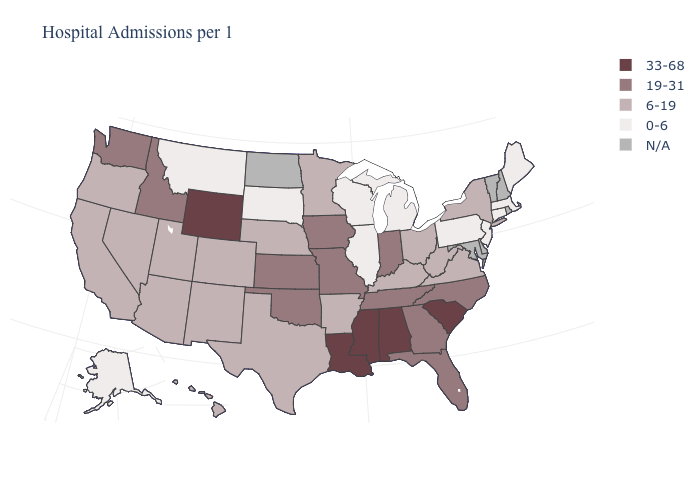Which states have the lowest value in the South?
Answer briefly. Arkansas, Kentucky, Texas, Virginia, West Virginia. Among the states that border Nevada , does Idaho have the highest value?
Quick response, please. Yes. What is the highest value in the USA?
Concise answer only. 33-68. Name the states that have a value in the range 19-31?
Answer briefly. Florida, Georgia, Idaho, Indiana, Iowa, Kansas, Missouri, North Carolina, Oklahoma, Tennessee, Washington. Name the states that have a value in the range 0-6?
Give a very brief answer. Alaska, Connecticut, Illinois, Maine, Massachusetts, Michigan, Montana, New Jersey, Pennsylvania, South Dakota, Wisconsin. What is the lowest value in the USA?
Be succinct. 0-6. Does the map have missing data?
Keep it brief. Yes. Which states have the highest value in the USA?
Be succinct. Alabama, Louisiana, Mississippi, South Carolina, Wyoming. Does the map have missing data?
Concise answer only. Yes. Which states have the lowest value in the USA?
Concise answer only. Alaska, Connecticut, Illinois, Maine, Massachusetts, Michigan, Montana, New Jersey, Pennsylvania, South Dakota, Wisconsin. Which states have the highest value in the USA?
Quick response, please. Alabama, Louisiana, Mississippi, South Carolina, Wyoming. What is the value of California?
Answer briefly. 6-19. Does Connecticut have the lowest value in the USA?
Be succinct. Yes. How many symbols are there in the legend?
Give a very brief answer. 5. What is the highest value in states that border Virginia?
Quick response, please. 19-31. 